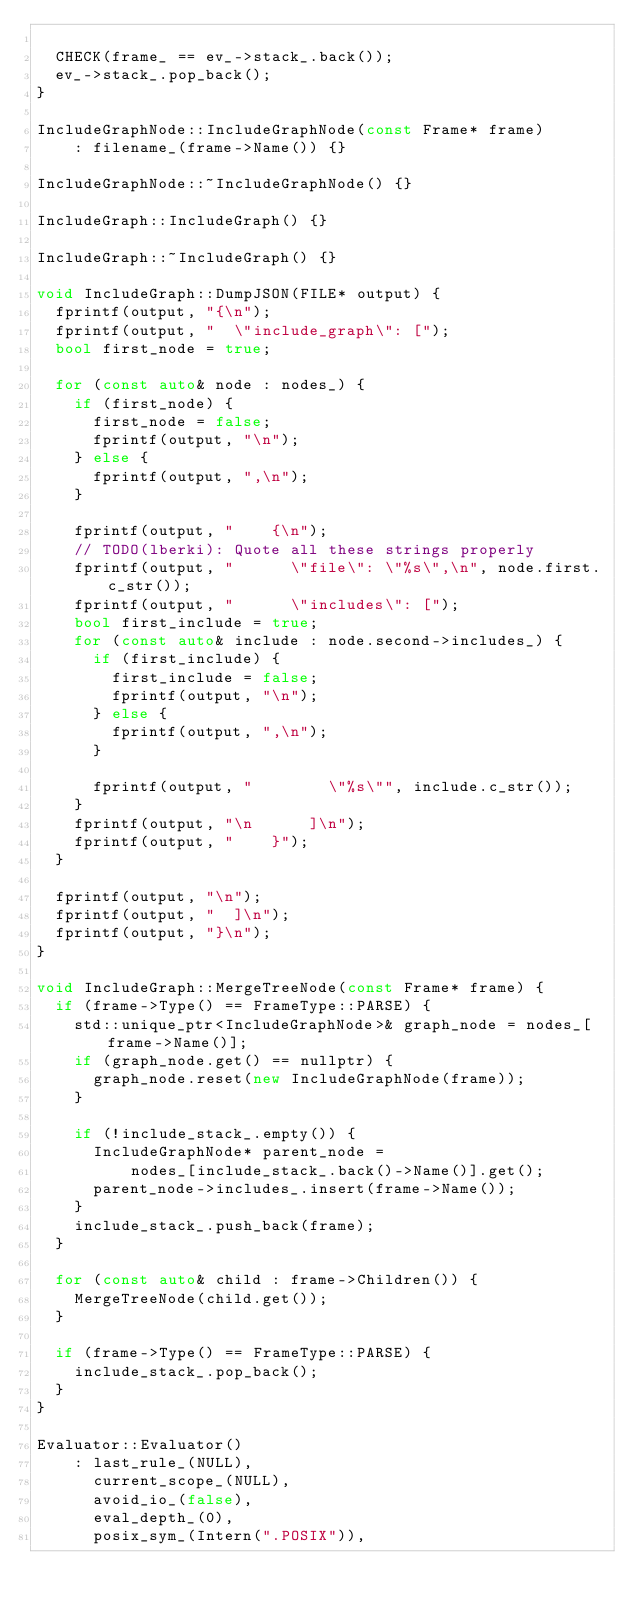Convert code to text. <code><loc_0><loc_0><loc_500><loc_500><_C++_>
  CHECK(frame_ == ev_->stack_.back());
  ev_->stack_.pop_back();
}

IncludeGraphNode::IncludeGraphNode(const Frame* frame)
    : filename_(frame->Name()) {}

IncludeGraphNode::~IncludeGraphNode() {}

IncludeGraph::IncludeGraph() {}

IncludeGraph::~IncludeGraph() {}

void IncludeGraph::DumpJSON(FILE* output) {
  fprintf(output, "{\n");
  fprintf(output, "  \"include_graph\": [");
  bool first_node = true;

  for (const auto& node : nodes_) {
    if (first_node) {
      first_node = false;
      fprintf(output, "\n");
    } else {
      fprintf(output, ",\n");
    }

    fprintf(output, "    {\n");
    // TODO(lberki): Quote all these strings properly
    fprintf(output, "      \"file\": \"%s\",\n", node.first.c_str());
    fprintf(output, "      \"includes\": [");
    bool first_include = true;
    for (const auto& include : node.second->includes_) {
      if (first_include) {
        first_include = false;
        fprintf(output, "\n");
      } else {
        fprintf(output, ",\n");
      }

      fprintf(output, "        \"%s\"", include.c_str());
    }
    fprintf(output, "\n      ]\n");
    fprintf(output, "    }");
  }

  fprintf(output, "\n");
  fprintf(output, "  ]\n");
  fprintf(output, "}\n");
}

void IncludeGraph::MergeTreeNode(const Frame* frame) {
  if (frame->Type() == FrameType::PARSE) {
    std::unique_ptr<IncludeGraphNode>& graph_node = nodes_[frame->Name()];
    if (graph_node.get() == nullptr) {
      graph_node.reset(new IncludeGraphNode(frame));
    }

    if (!include_stack_.empty()) {
      IncludeGraphNode* parent_node =
          nodes_[include_stack_.back()->Name()].get();
      parent_node->includes_.insert(frame->Name());
    }
    include_stack_.push_back(frame);
  }

  for (const auto& child : frame->Children()) {
    MergeTreeNode(child.get());
  }

  if (frame->Type() == FrameType::PARSE) {
    include_stack_.pop_back();
  }
}

Evaluator::Evaluator()
    : last_rule_(NULL),
      current_scope_(NULL),
      avoid_io_(false),
      eval_depth_(0),
      posix_sym_(Intern(".POSIX")),</code> 